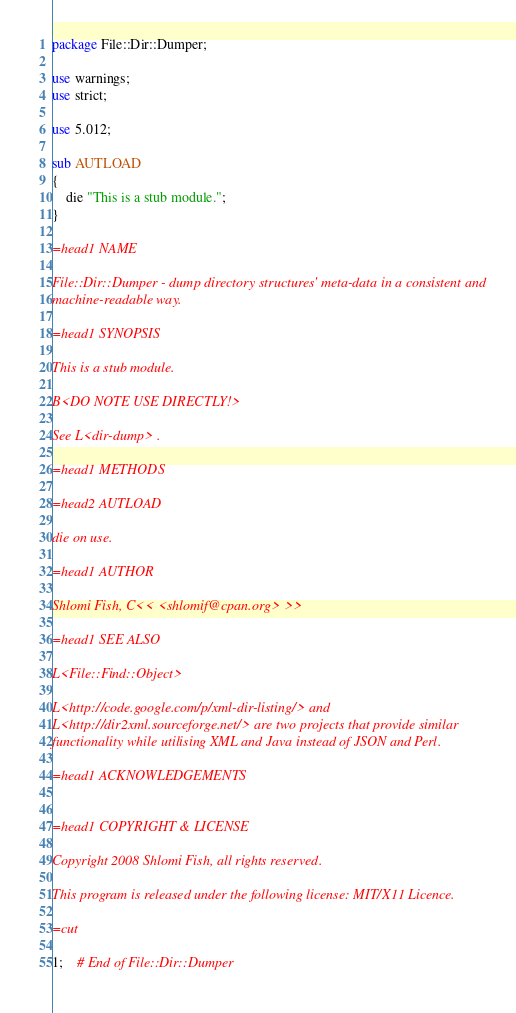<code> <loc_0><loc_0><loc_500><loc_500><_Perl_>package File::Dir::Dumper;

use warnings;
use strict;

use 5.012;

sub AUTLOAD
{
    die "This is a stub module.";
}

=head1 NAME

File::Dir::Dumper - dump directory structures' meta-data in a consistent and
machine-readable way.

=head1 SYNOPSIS

This is a stub module.

B<DO NOTE USE DIRECTLY!>

See L<dir-dump> .

=head1 METHODS

=head2 AUTLOAD

die on use.

=head1 AUTHOR

Shlomi Fish, C<< <shlomif@cpan.org> >>

=head1 SEE ALSO

L<File::Find::Object>

L<http://code.google.com/p/xml-dir-listing/> and
L<http://dir2xml.sourceforge.net/> are two projects that provide similar
functionality while utilising XML and Java instead of JSON and Perl.

=head1 ACKNOWLEDGEMENTS


=head1 COPYRIGHT & LICENSE

Copyright 2008 Shlomi Fish, all rights reserved.

This program is released under the following license: MIT/X11 Licence.

=cut

1;    # End of File::Dir::Dumper
</code> 